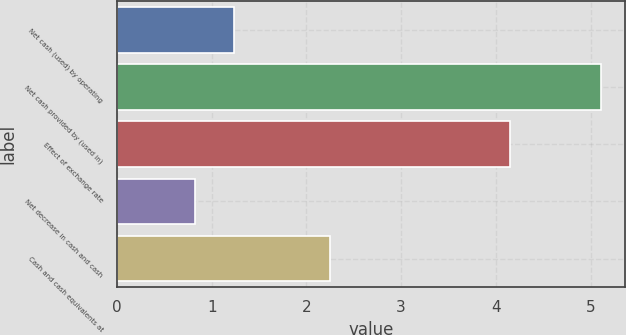Convert chart to OTSL. <chart><loc_0><loc_0><loc_500><loc_500><bar_chart><fcel>Net cash (used) by operating<fcel>Net cash provided by (used in)<fcel>Effect of exchange rate<fcel>Net decrease in cash and cash<fcel>Cash and cash equivalents at<nl><fcel>1.23<fcel>5.11<fcel>4.15<fcel>0.82<fcel>2.25<nl></chart> 